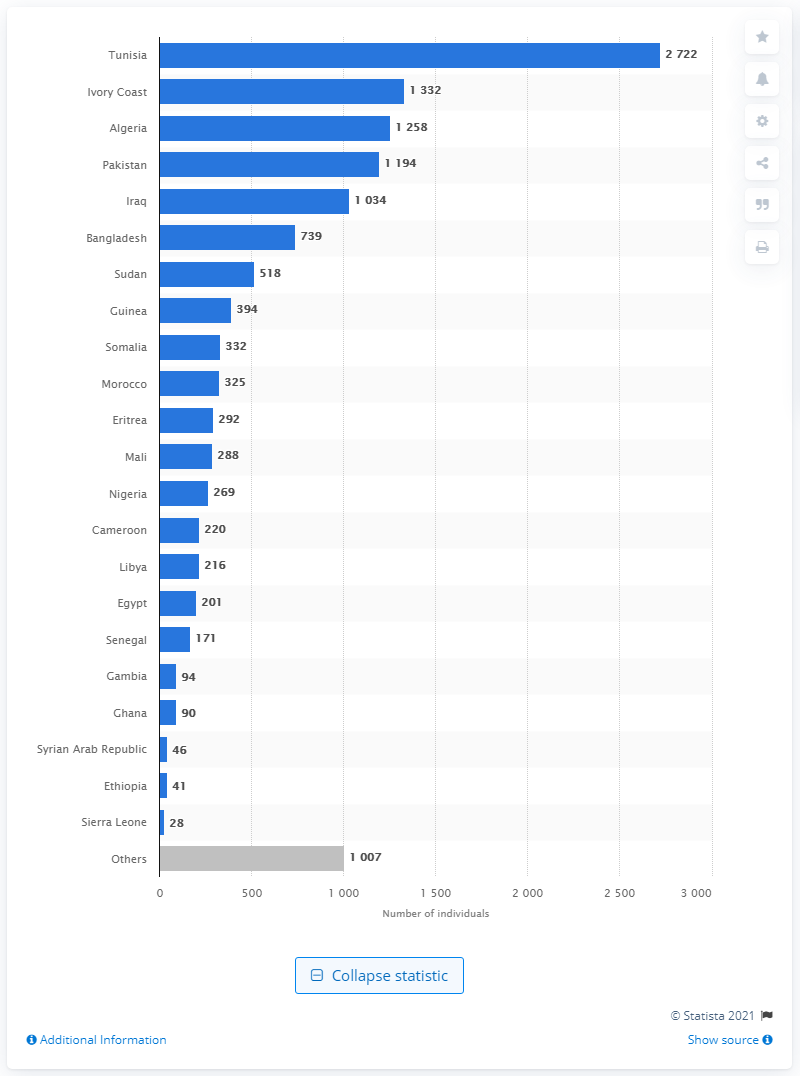Mention a couple of crucial points in this snapshot. The most common country of origin declared by individuals upon arrival in Italy was Tunisia. During the period of January 2019 to January 2020, a total of 2,722 Tunisians arrived in Italy. 